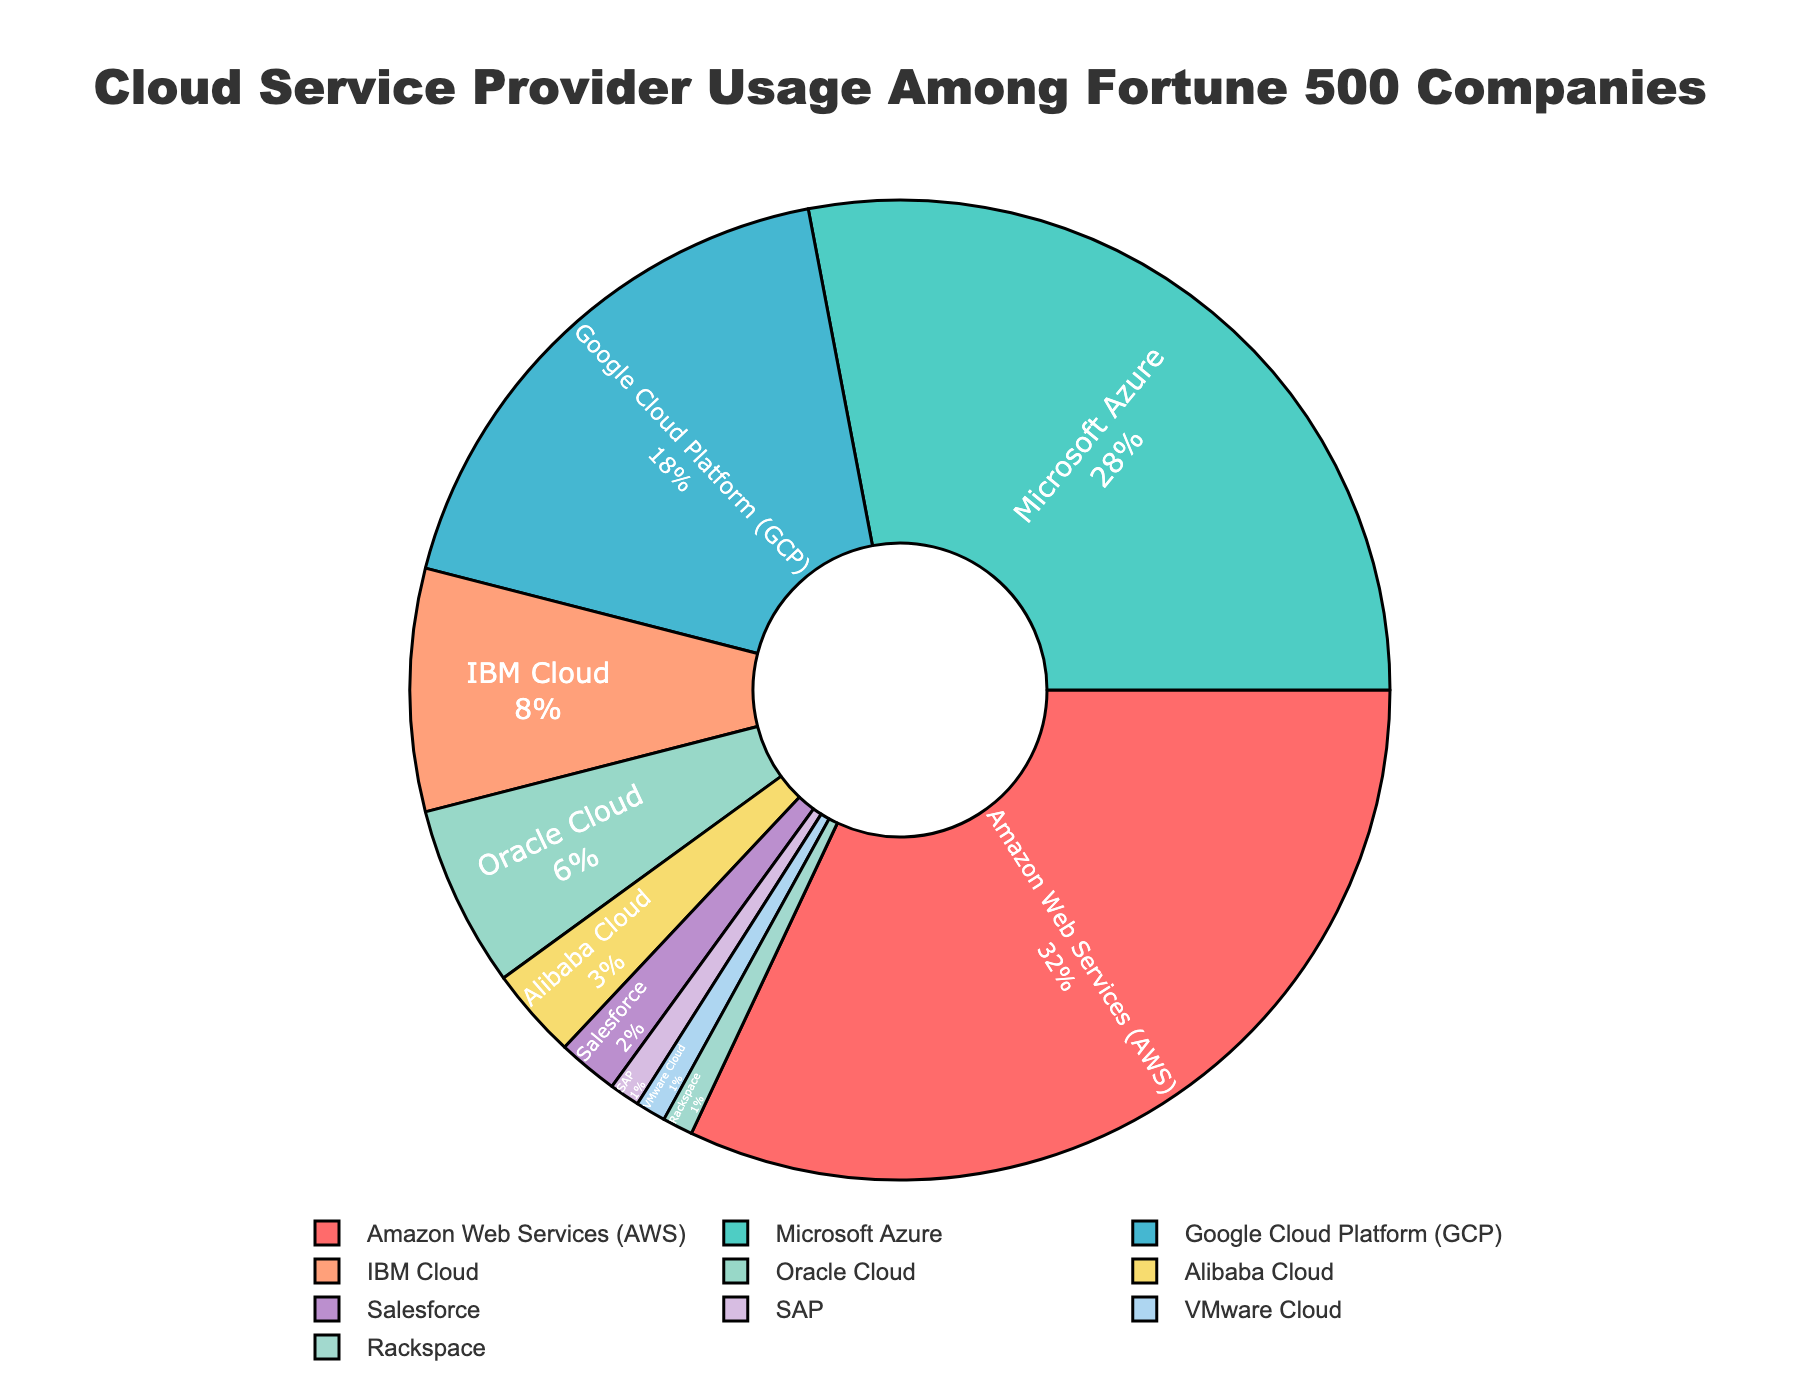Which cloud provider has the largest market share? The figure shows the percentage distribution of cloud service usage among companies. Amazon Web Services (AWS) has the highest percentage, indicating it has the largest market share.
Answer: Amazon Web Services (AWS) What is the combined market share of Google Cloud Platform (GCP) and Microsoft Azure? To find the combined market share, add the percentages of Google Cloud Platform (GCP) and Microsoft Azure. GCP is 18% and Microsoft Azure is 28%, so 18 + 28 = 46%.
Answer: 46% Which cloud provider has a market share closest to 10%? The figure shows IBM Cloud has an 8% market share, which is closest to 10%.
Answer: IBM Cloud How much larger is AWS's market share compared to Oracle Cloud's? Subtract Oracle Cloud's percentage from AWS's percentage. AWS is 32% and Oracle Cloud is 6%, so 32 - 6 = 26%.
Answer: 26% If you combined the market share of Alibaba Cloud, Salesforce, SAP, VMware Cloud, and Rackspace, would it exceed that of Google Cloud Platform (GCP)? Add the percentages of Alibaba Cloud (3%), Salesforce (2%), SAP (1%), VMware Cloud (1%), and Rackspace (1%). Their total is 3 + 2 + 1 + 1 + 1 = 8%, which does not exceed GCP's market share of 18%.
Answer: No Among the cloud providers, which one has the smallest market share? The figure shows that SAP, VMware Cloud, and Rackspace each have the smallest market shares at 1%.
Answer: SAP, VMware Cloud, Rackspace Which cloud providers have a market share of less than 5%? According to the figure, Alibaba Cloud (3%), Salesforce (2%), SAP (1%), VMware Cloud (1%), and Rackspace (1%) have market shares of less than 5%.
Answer: Alibaba Cloud, Salesforce, SAP, VMware Cloud, Rackspace If you exclude the top three providers (AWS, Microsoft Azure, and GCP), what is the total market share of the remaining providers? Subtract the sum of the top three providers' market shares from 100%. AWS is 32%, Microsoft Azure is 28%, GCP is 18%. Their sum is 32 + 28 + 18 = 78%. The remaining market share is 100 - 78 = 22%.
Answer: 22% What color represents Oracle Cloud in the chart? The figure uses specific colors for each provider. Oracle Cloud is represented by the color '#98D8C8', which corresponds to a light green color.
Answer: Light green Among the providers with less than 10% market share, which one has the highest percentage? From the figure, IBM Cloud has 8%, which is the highest percentage among those with less than 10% market share.
Answer: IBM Cloud 